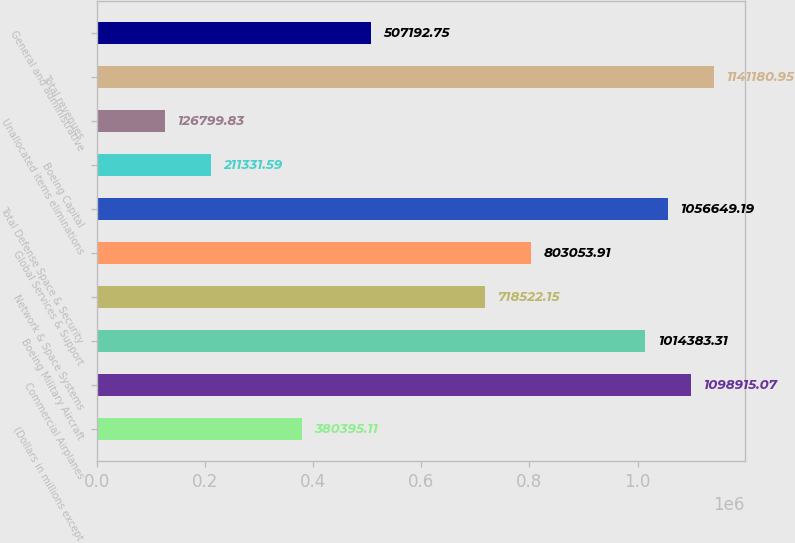Convert chart. <chart><loc_0><loc_0><loc_500><loc_500><bar_chart><fcel>(Dollars in millions except<fcel>Commercial Airplanes<fcel>Boeing Military Aircraft<fcel>Network & Space Systems<fcel>Global Services & Support<fcel>Total Defense Space & Security<fcel>Boeing Capital<fcel>Unallocated items eliminations<fcel>Total revenues<fcel>General and administrative<nl><fcel>380395<fcel>1.09892e+06<fcel>1.01438e+06<fcel>718522<fcel>803054<fcel>1.05665e+06<fcel>211332<fcel>126800<fcel>1.14118e+06<fcel>507193<nl></chart> 